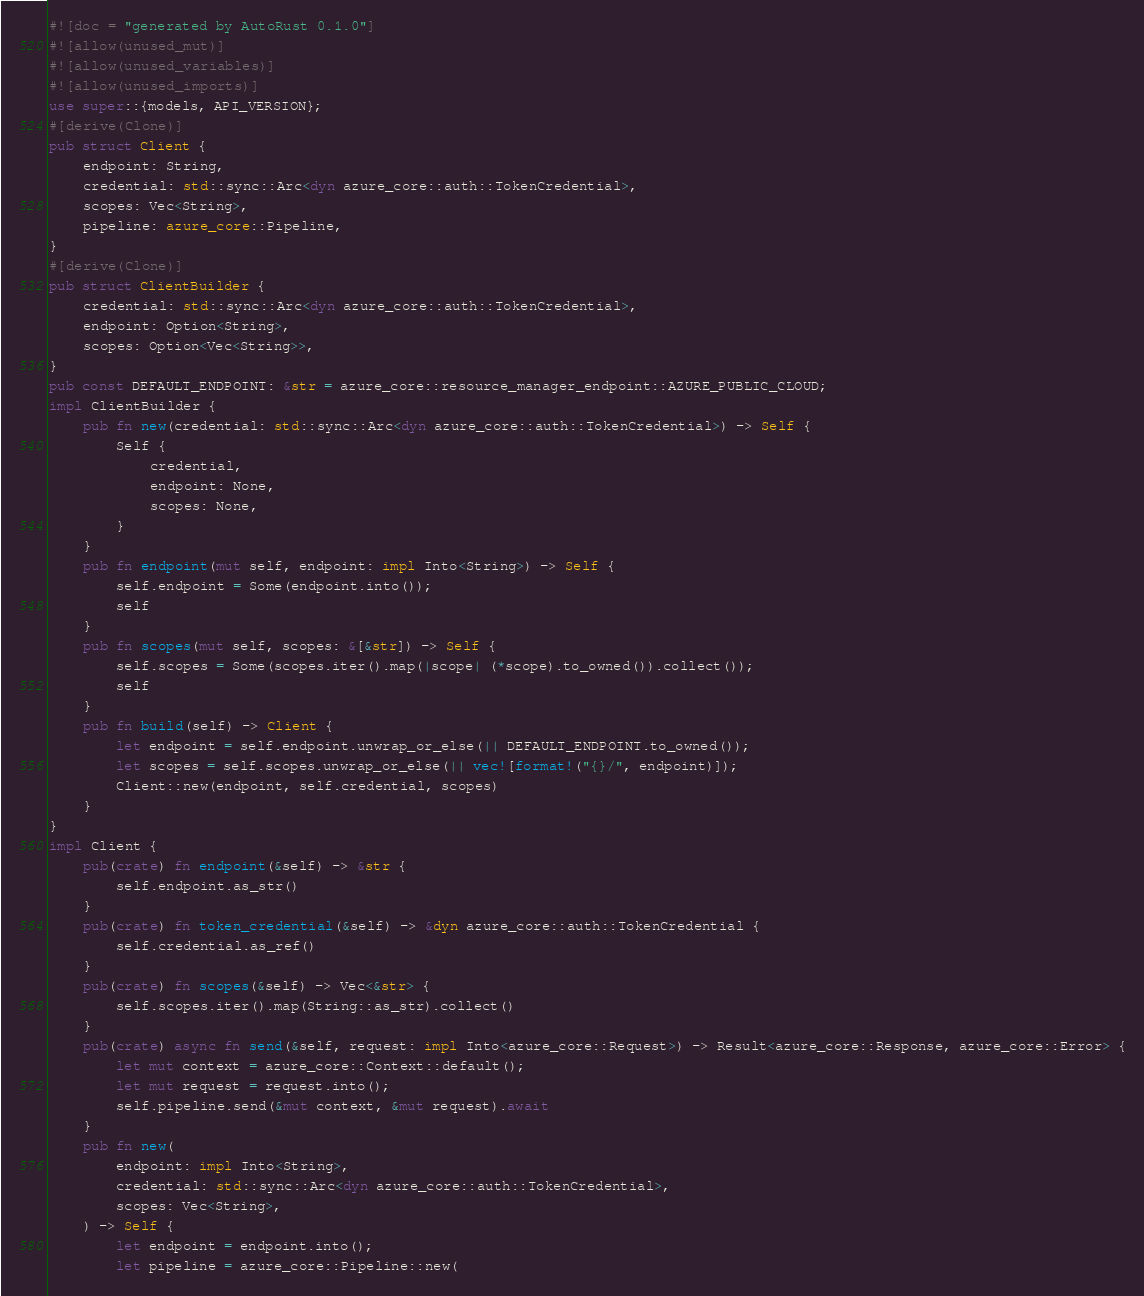<code> <loc_0><loc_0><loc_500><loc_500><_Rust_>#![doc = "generated by AutoRust 0.1.0"]
#![allow(unused_mut)]
#![allow(unused_variables)]
#![allow(unused_imports)]
use super::{models, API_VERSION};
#[derive(Clone)]
pub struct Client {
    endpoint: String,
    credential: std::sync::Arc<dyn azure_core::auth::TokenCredential>,
    scopes: Vec<String>,
    pipeline: azure_core::Pipeline,
}
#[derive(Clone)]
pub struct ClientBuilder {
    credential: std::sync::Arc<dyn azure_core::auth::TokenCredential>,
    endpoint: Option<String>,
    scopes: Option<Vec<String>>,
}
pub const DEFAULT_ENDPOINT: &str = azure_core::resource_manager_endpoint::AZURE_PUBLIC_CLOUD;
impl ClientBuilder {
    pub fn new(credential: std::sync::Arc<dyn azure_core::auth::TokenCredential>) -> Self {
        Self {
            credential,
            endpoint: None,
            scopes: None,
        }
    }
    pub fn endpoint(mut self, endpoint: impl Into<String>) -> Self {
        self.endpoint = Some(endpoint.into());
        self
    }
    pub fn scopes(mut self, scopes: &[&str]) -> Self {
        self.scopes = Some(scopes.iter().map(|scope| (*scope).to_owned()).collect());
        self
    }
    pub fn build(self) -> Client {
        let endpoint = self.endpoint.unwrap_or_else(|| DEFAULT_ENDPOINT.to_owned());
        let scopes = self.scopes.unwrap_or_else(|| vec![format!("{}/", endpoint)]);
        Client::new(endpoint, self.credential, scopes)
    }
}
impl Client {
    pub(crate) fn endpoint(&self) -> &str {
        self.endpoint.as_str()
    }
    pub(crate) fn token_credential(&self) -> &dyn azure_core::auth::TokenCredential {
        self.credential.as_ref()
    }
    pub(crate) fn scopes(&self) -> Vec<&str> {
        self.scopes.iter().map(String::as_str).collect()
    }
    pub(crate) async fn send(&self, request: impl Into<azure_core::Request>) -> Result<azure_core::Response, azure_core::Error> {
        let mut context = azure_core::Context::default();
        let mut request = request.into();
        self.pipeline.send(&mut context, &mut request).await
    }
    pub fn new(
        endpoint: impl Into<String>,
        credential: std::sync::Arc<dyn azure_core::auth::TokenCredential>,
        scopes: Vec<String>,
    ) -> Self {
        let endpoint = endpoint.into();
        let pipeline = azure_core::Pipeline::new(</code> 